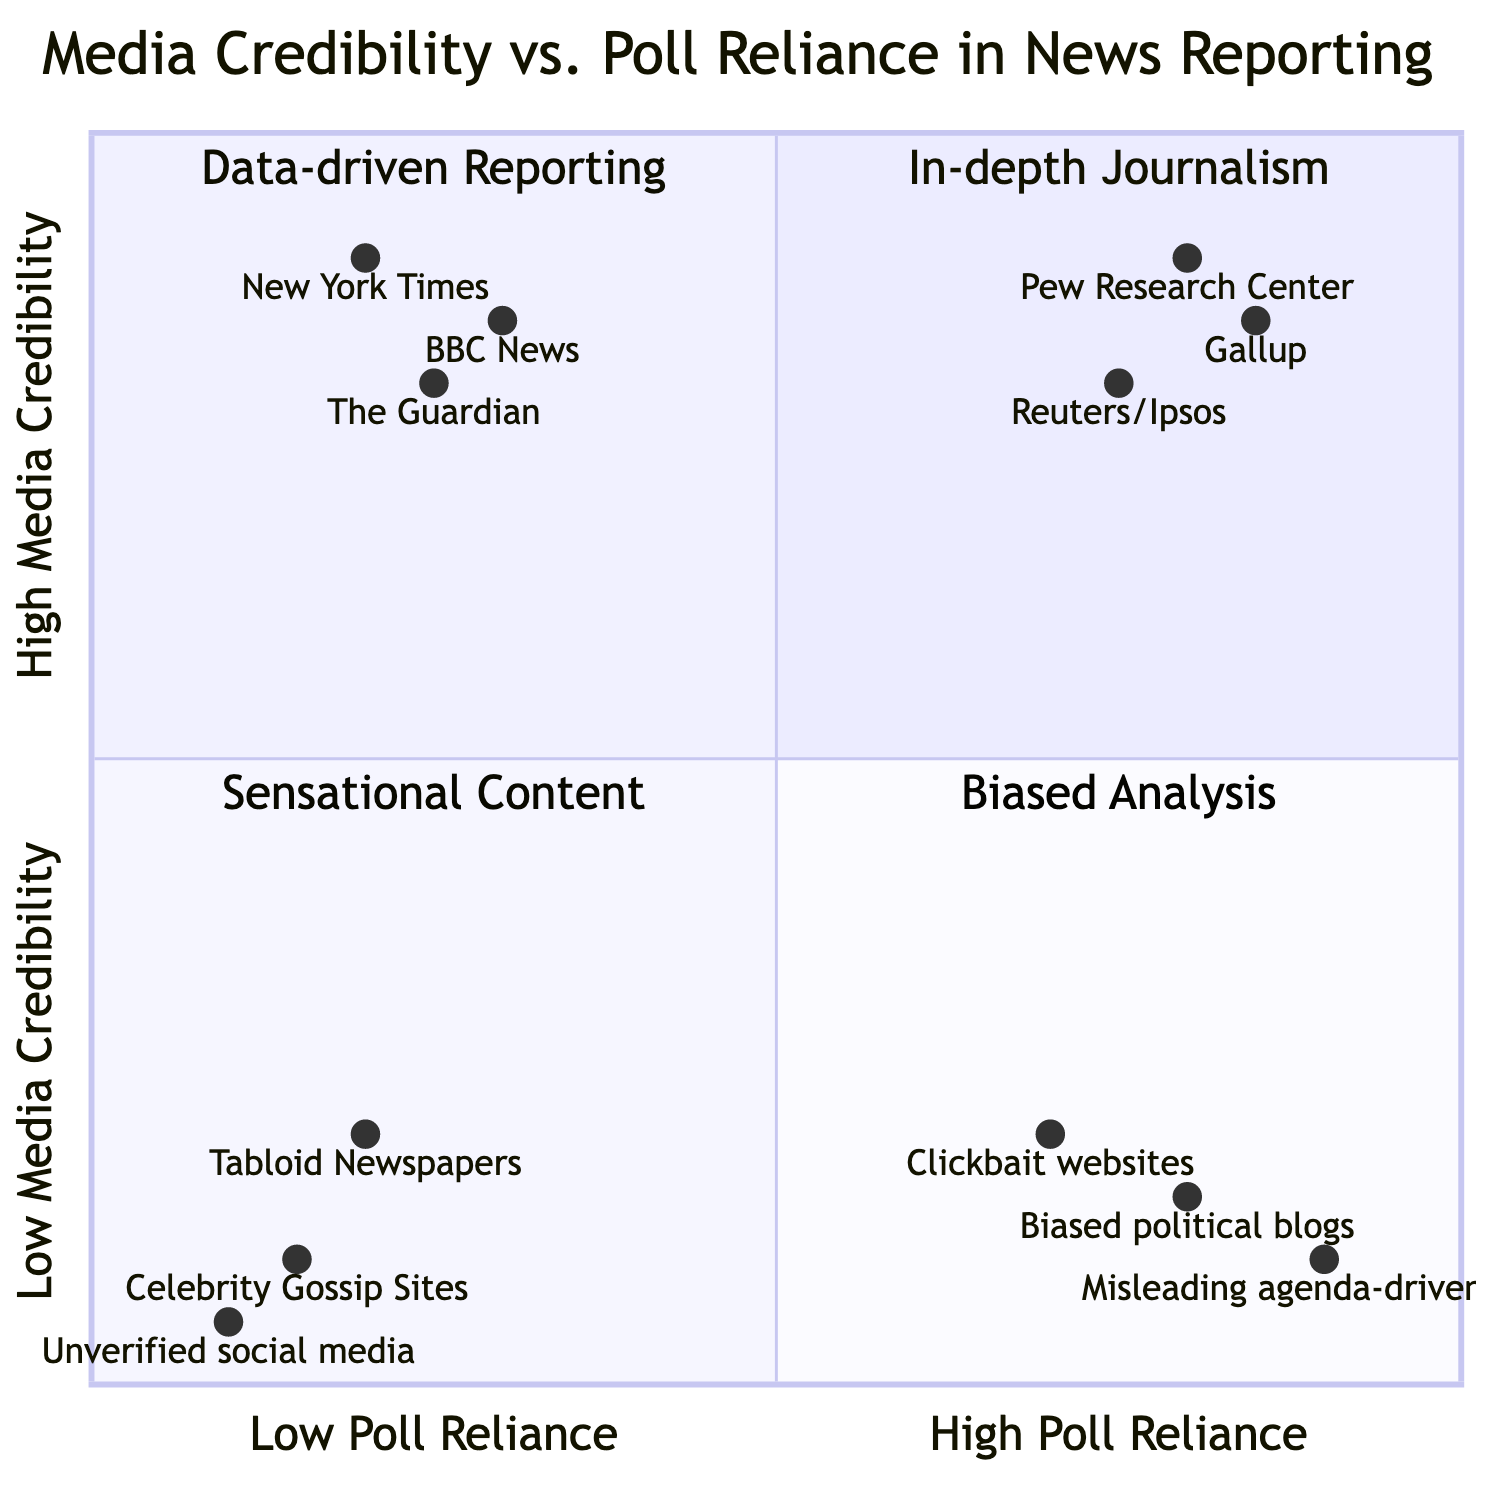What is the highest media credibility score in the diagram? The highest media credibility score is represented by the Y-axis that reaches its maximum at 1. The highest positioned point with a credibility score closest to this maximum is Pew Research Center, which has a score of 0.9.
Answer: 0.9 Which outlet has the least reliance on polls? The outlet with the least reliance on polls is located on the far left of the X-axis. The outlet farthest to the left is Unverified social media accounts with a poll reliance score of 0.1.
Answer: Unverified social media accounts How many outlets exhibit low media credibility and high poll reliance? To find the count, we check the quadrant in the lower right section. The outlets listed here include Clickbait websites, Biased political blogs, and Misleading agenda-driven sites, totaling three outlets.
Answer: 3 What characteristics do outlets in the "High Media Credibility, Low Poll Reliance" quadrant share? The characteristics for this quadrant include in-depth investigative journalism, expert analysis and opinions, and limited use of polls to complement reporting. All these descriptions help characterize the outlets that belong to this quadrant.
Answer: In-depth investigative journalism, expert analysis and opinions, limited use of polls Which example falls under "Low Media Credibility, Low Poll Reliance"? The quadrant in the lower left section represents this category. The outlets in this quadrant include Tabloid Newspapers, Celebrity Gossip Sites, and Unverified social media accounts. Among these, "Tabloid Newspapers" serves as a representative example.
Answer: Tabloid Newspapers What is the relationship between "Poll Reliance" and "Media Credibility" for "Clickbait websites"? Clickbait websites are located in the quadrant with high poll reliance and low media credibility. This position shows that they have a significant reliance on polls but do not possess credibility in their reporting, indicating a likely bias.
Answer: High poll reliance, low media credibility What outlet exemplifies data-driven reporting? The quadrant dedicated to "Data-driven Reporting" contains outlets that heavily rely on poll data for their stories. Among these, Pew Research Center is a strong representation.
Answer: Pew Research Center How many examples are listed under "High Media Credibility, High Poll Reliance"? To find the number, we look at the quadrant and count the examples: Pew Research Center, Gallup, and Reuters/Ipsos. This totals three distinct examples.
Answer: 3 What is a characteristic of "Biased Analysis"? The characteristic of "Biased Analysis" as represented in the quadrant includes the selective use of poll data to support bias, lack of transparency in reporting, and exaggerated or skewed statistics.
Answer: Selective use of poll data to support bias 